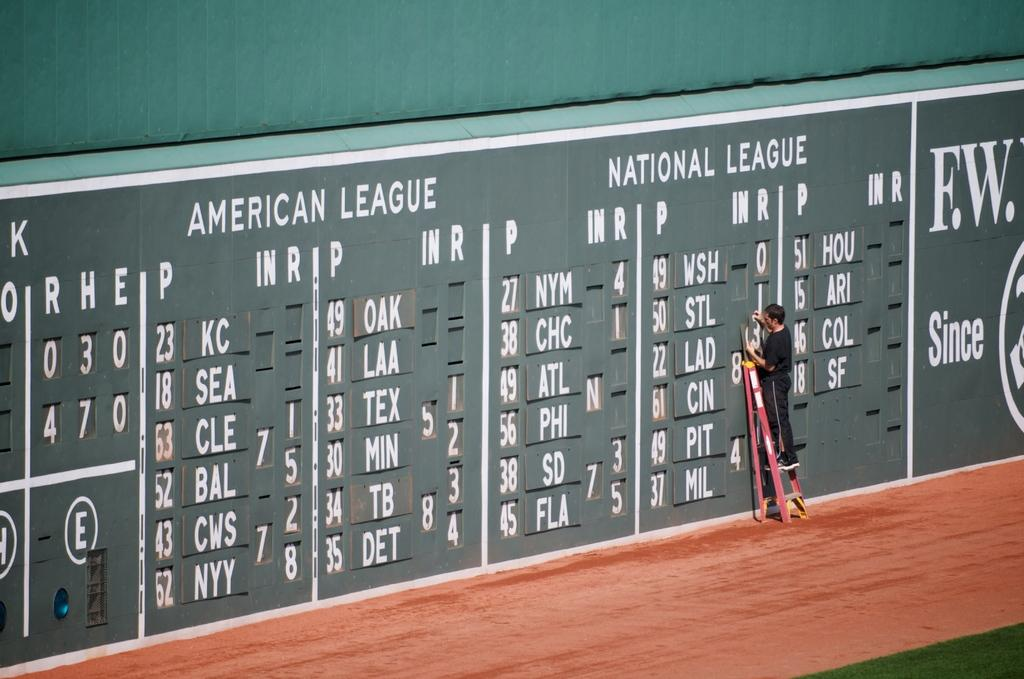<image>
Summarize the visual content of the image. A basebal chart for both the American Leaque and the National Leaque. 